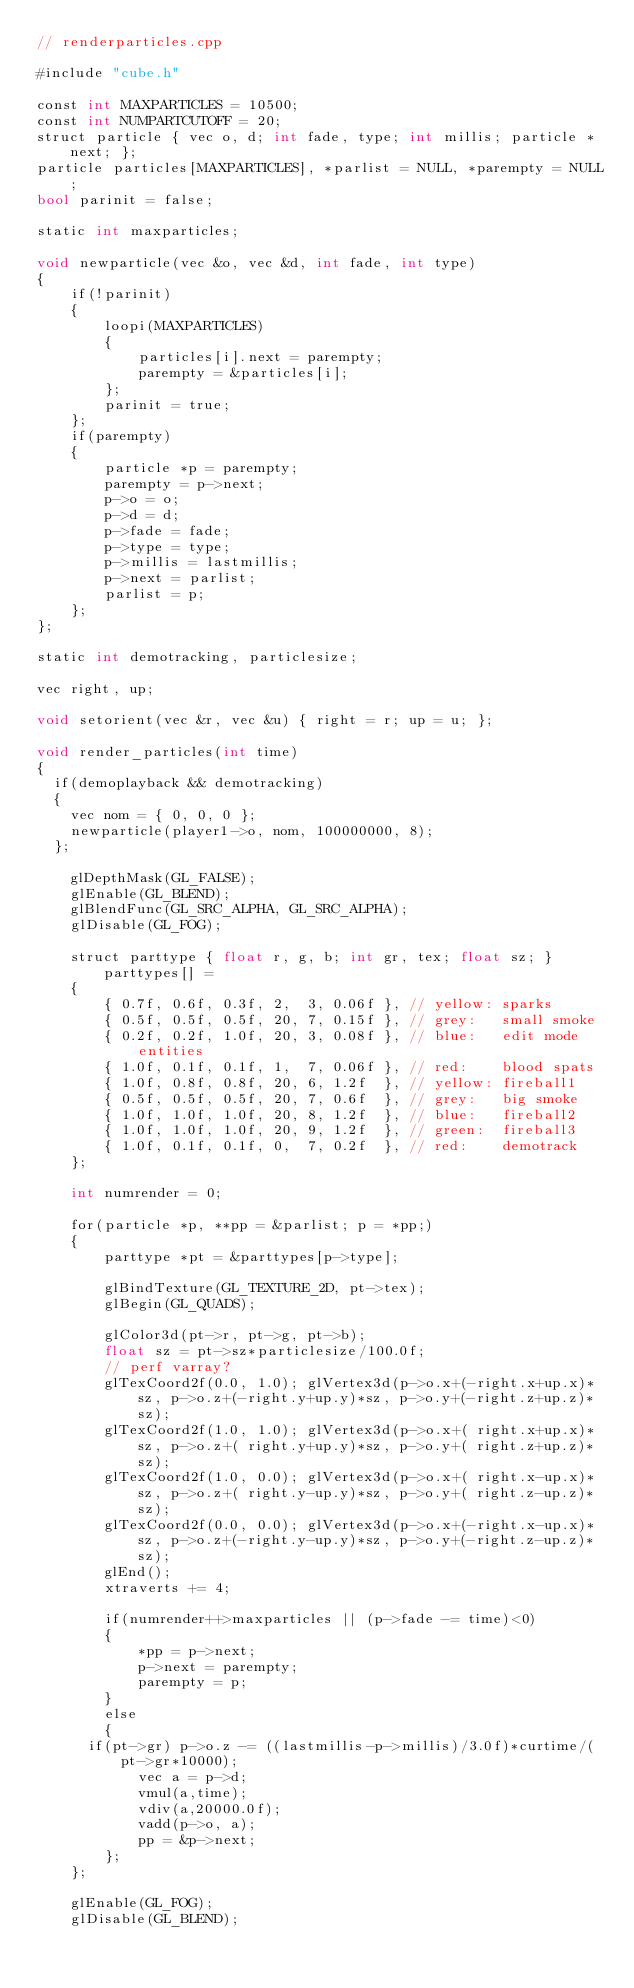Convert code to text. <code><loc_0><loc_0><loc_500><loc_500><_ObjectiveC_>// renderparticles.cpp

#include "cube.h"

const int MAXPARTICLES = 10500;
const int NUMPARTCUTOFF = 20;
struct particle { vec o, d; int fade, type; int millis; particle *next; };
particle particles[MAXPARTICLES], *parlist = NULL, *parempty = NULL;
bool parinit = false;

static int maxparticles;

void newparticle(vec &o, vec &d, int fade, int type)
{
    if(!parinit)
    {
        loopi(MAXPARTICLES)
        {
            particles[i].next = parempty;
            parempty = &particles[i];
        };
        parinit = true;
    };
    if(parempty)
    {
        particle *p = parempty;
        parempty = p->next;
        p->o = o;
        p->d = d;
        p->fade = fade;
        p->type = type;
        p->millis = lastmillis;
        p->next = parlist;
        parlist = p;
    };
};

static int demotracking, particlesize;

vec right, up;

void setorient(vec &r, vec &u) { right = r; up = u; };

void render_particles(int time)
{
	if(demoplayback && demotracking)
	{
		vec nom = { 0, 0, 0 };
		newparticle(player1->o, nom, 100000000, 8);
	};

    glDepthMask(GL_FALSE);
    glEnable(GL_BLEND);
    glBlendFunc(GL_SRC_ALPHA, GL_SRC_ALPHA);
    glDisable(GL_FOG);

    struct parttype { float r, g, b; int gr, tex; float sz; } parttypes[] =
    {
        { 0.7f, 0.6f, 0.3f, 2,  3, 0.06f }, // yellow: sparks
        { 0.5f, 0.5f, 0.5f, 20, 7, 0.15f }, // grey:   small smoke
        { 0.2f, 0.2f, 1.0f, 20, 3, 0.08f }, // blue:   edit mode entities
        { 1.0f, 0.1f, 0.1f, 1,  7, 0.06f }, // red:    blood spats
        { 1.0f, 0.8f, 0.8f, 20, 6, 1.2f  }, // yellow: fireball1
        { 0.5f, 0.5f, 0.5f, 20, 7, 0.6f  }, // grey:   big smoke
        { 1.0f, 1.0f, 1.0f, 20, 8, 1.2f  }, // blue:   fireball2
        { 1.0f, 1.0f, 1.0f, 20, 9, 1.2f  }, // green:  fireball3
        { 1.0f, 0.1f, 0.1f, 0,  7, 0.2f  }, // red:    demotrack
    };

    int numrender = 0;

    for(particle *p, **pp = &parlist; p = *pp;)
    {
        parttype *pt = &parttypes[p->type];

        glBindTexture(GL_TEXTURE_2D, pt->tex);
        glBegin(GL_QUADS);

        glColor3d(pt->r, pt->g, pt->b);
        float sz = pt->sz*particlesize/100.0f;
        // perf varray?
        glTexCoord2f(0.0, 1.0); glVertex3d(p->o.x+(-right.x+up.x)*sz, p->o.z+(-right.y+up.y)*sz, p->o.y+(-right.z+up.z)*sz);
        glTexCoord2f(1.0, 1.0); glVertex3d(p->o.x+( right.x+up.x)*sz, p->o.z+( right.y+up.y)*sz, p->o.y+( right.z+up.z)*sz);
        glTexCoord2f(1.0, 0.0); glVertex3d(p->o.x+( right.x-up.x)*sz, p->o.z+( right.y-up.y)*sz, p->o.y+( right.z-up.z)*sz);
        glTexCoord2f(0.0, 0.0); glVertex3d(p->o.x+(-right.x-up.x)*sz, p->o.z+(-right.y-up.y)*sz, p->o.y+(-right.z-up.z)*sz);
        glEnd();
        xtraverts += 4;

        if(numrender++>maxparticles || (p->fade -= time)<0)
        {
            *pp = p->next;
            p->next = parempty;
            parempty = p;
        }
        else
        {
			if(pt->gr) p->o.z -= ((lastmillis-p->millis)/3.0f)*curtime/(pt->gr*10000);
            vec a = p->d;
            vmul(a,time);
            vdiv(a,20000.0f);
            vadd(p->o, a);
            pp = &p->next;
        };
    };

    glEnable(GL_FOG);
    glDisable(GL_BLEND);</code> 